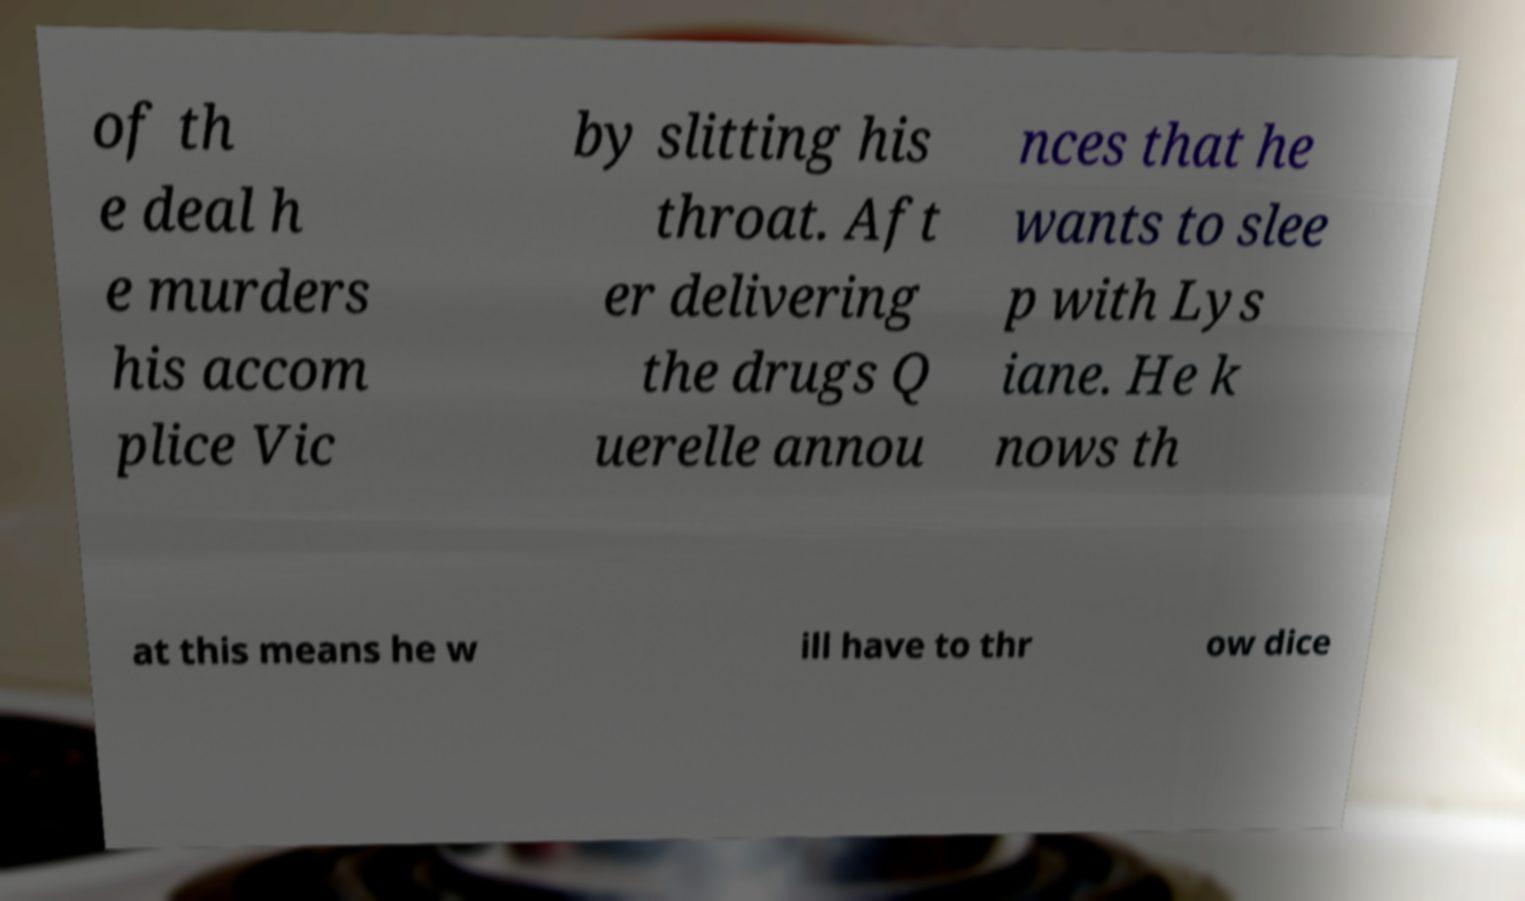Can you accurately transcribe the text from the provided image for me? of th e deal h e murders his accom plice Vic by slitting his throat. Aft er delivering the drugs Q uerelle annou nces that he wants to slee p with Lys iane. He k nows th at this means he w ill have to thr ow dice 